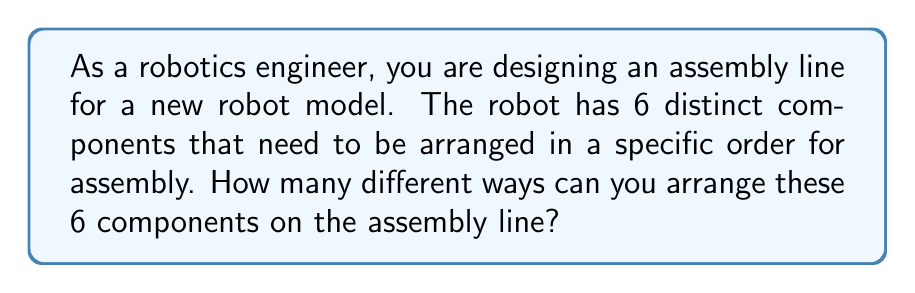Provide a solution to this math problem. Let's approach this step-by-step:

1) This problem is a classic example of permutation. We need to arrange 6 distinct objects (robot components) in a line.

2) In permutation problems, the order matters. Each different arrangement is considered a unique permutation.

3) The formula for permutation of n distinct objects is:

   $$P(n) = n!$$

   Where $n!$ (n factorial) is the product of all positive integers less than or equal to n.

4) In this case, $n = 6$ (as there are 6 distinct components).

5) So, we need to calculate:

   $$P(6) = 6!$$

6) Let's expand this:
   
   $$6! = 6 \times 5 \times 4 \times 3 \times 2 \times 1 = 720$$

Therefore, there are 720 different ways to arrange the 6 robot components on the assembly line.
Answer: 720 